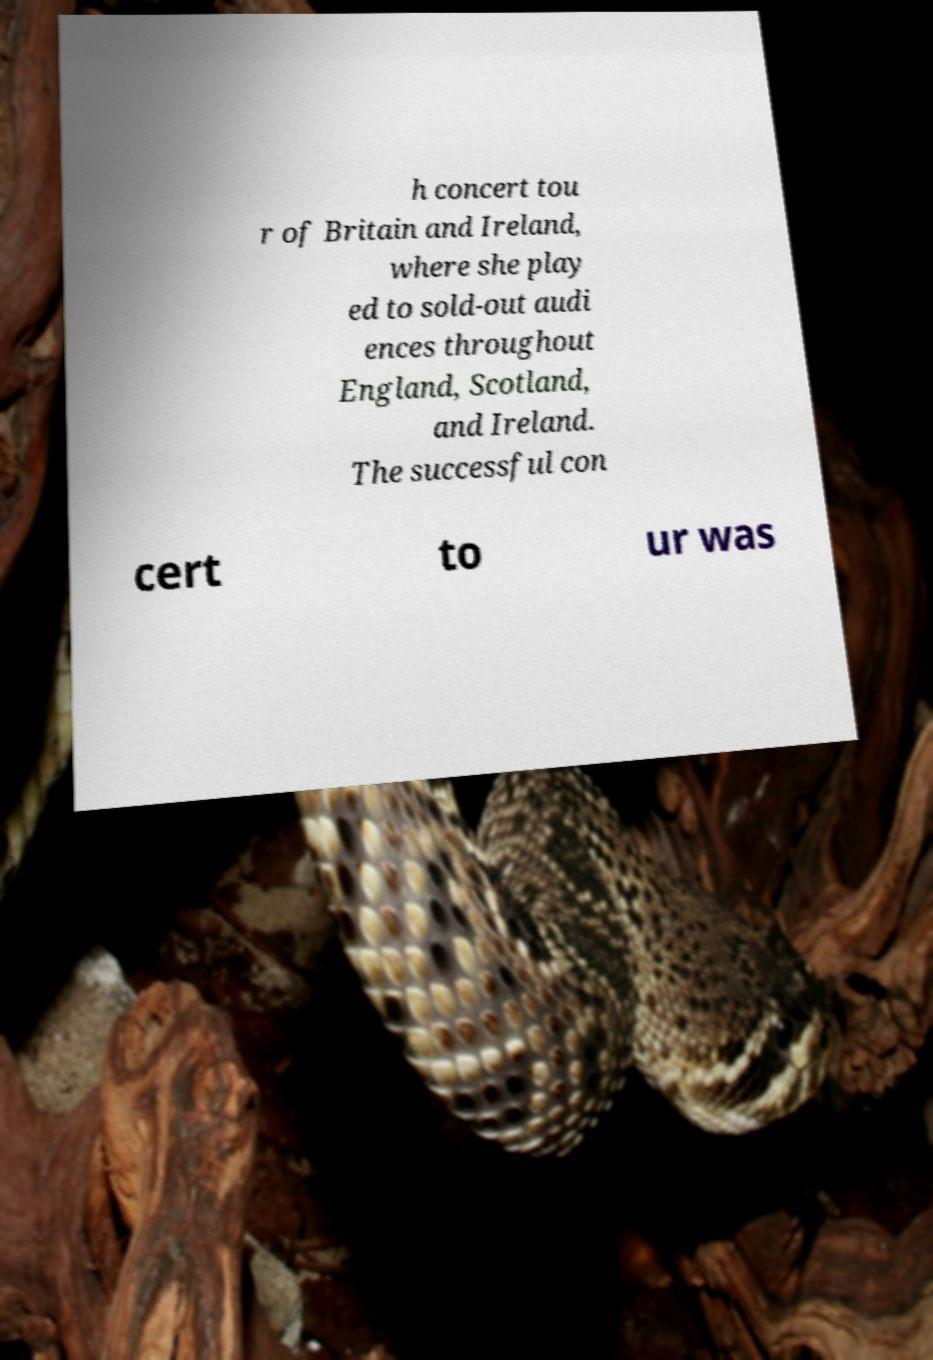Please identify and transcribe the text found in this image. h concert tou r of Britain and Ireland, where she play ed to sold-out audi ences throughout England, Scotland, and Ireland. The successful con cert to ur was 